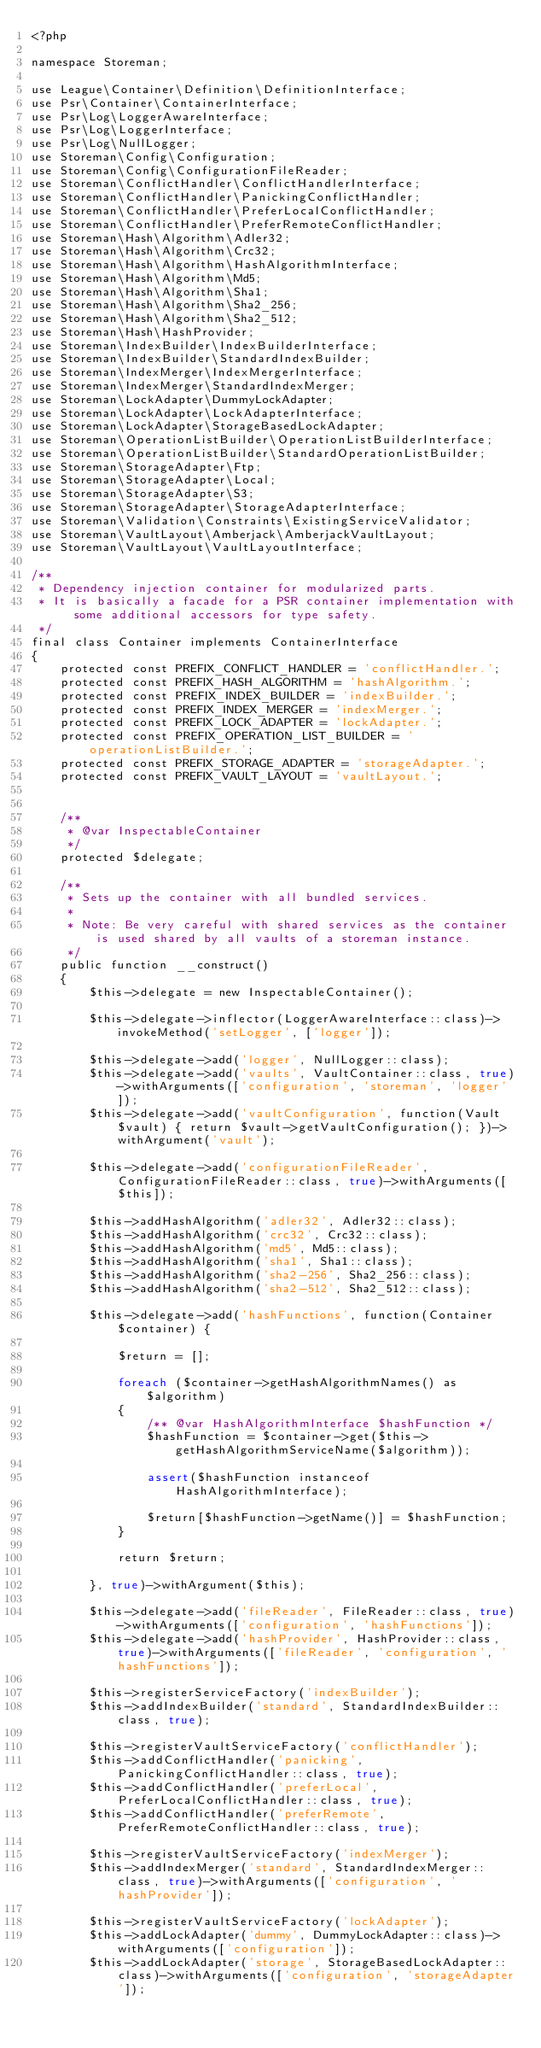Convert code to text. <code><loc_0><loc_0><loc_500><loc_500><_PHP_><?php

namespace Storeman;

use League\Container\Definition\DefinitionInterface;
use Psr\Container\ContainerInterface;
use Psr\Log\LoggerAwareInterface;
use Psr\Log\LoggerInterface;
use Psr\Log\NullLogger;
use Storeman\Config\Configuration;
use Storeman\Config\ConfigurationFileReader;
use Storeman\ConflictHandler\ConflictHandlerInterface;
use Storeman\ConflictHandler\PanickingConflictHandler;
use Storeman\ConflictHandler\PreferLocalConflictHandler;
use Storeman\ConflictHandler\PreferRemoteConflictHandler;
use Storeman\Hash\Algorithm\Adler32;
use Storeman\Hash\Algorithm\Crc32;
use Storeman\Hash\Algorithm\HashAlgorithmInterface;
use Storeman\Hash\Algorithm\Md5;
use Storeman\Hash\Algorithm\Sha1;
use Storeman\Hash\Algorithm\Sha2_256;
use Storeman\Hash\Algorithm\Sha2_512;
use Storeman\Hash\HashProvider;
use Storeman\IndexBuilder\IndexBuilderInterface;
use Storeman\IndexBuilder\StandardIndexBuilder;
use Storeman\IndexMerger\IndexMergerInterface;
use Storeman\IndexMerger\StandardIndexMerger;
use Storeman\LockAdapter\DummyLockAdapter;
use Storeman\LockAdapter\LockAdapterInterface;
use Storeman\LockAdapter\StorageBasedLockAdapter;
use Storeman\OperationListBuilder\OperationListBuilderInterface;
use Storeman\OperationListBuilder\StandardOperationListBuilder;
use Storeman\StorageAdapter\Ftp;
use Storeman\StorageAdapter\Local;
use Storeman\StorageAdapter\S3;
use Storeman\StorageAdapter\StorageAdapterInterface;
use Storeman\Validation\Constraints\ExistingServiceValidator;
use Storeman\VaultLayout\Amberjack\AmberjackVaultLayout;
use Storeman\VaultLayout\VaultLayoutInterface;

/**
 * Dependency injection container for modularized parts.
 * It is basically a facade for a PSR container implementation with some additional accessors for type safety.
 */
final class Container implements ContainerInterface
{
    protected const PREFIX_CONFLICT_HANDLER = 'conflictHandler.';
    protected const PREFIX_HASH_ALGORITHM = 'hashAlgorithm.';
    protected const PREFIX_INDEX_BUILDER = 'indexBuilder.';
    protected const PREFIX_INDEX_MERGER = 'indexMerger.';
    protected const PREFIX_LOCK_ADAPTER = 'lockAdapter.';
    protected const PREFIX_OPERATION_LIST_BUILDER = 'operationListBuilder.';
    protected const PREFIX_STORAGE_ADAPTER = 'storageAdapter.';
    protected const PREFIX_VAULT_LAYOUT = 'vaultLayout.';


    /**
     * @var InspectableContainer
     */
    protected $delegate;

    /**
     * Sets up the container with all bundled services.
     *
     * Note: Be very careful with shared services as the container is used shared by all vaults of a storeman instance.
     */
    public function __construct()
    {
        $this->delegate = new InspectableContainer();

        $this->delegate->inflector(LoggerAwareInterface::class)->invokeMethod('setLogger', ['logger']);

        $this->delegate->add('logger', NullLogger::class);
        $this->delegate->add('vaults', VaultContainer::class, true)->withArguments(['configuration', 'storeman', 'logger']);
        $this->delegate->add('vaultConfiguration', function(Vault $vault) { return $vault->getVaultConfiguration(); })->withArgument('vault');

        $this->delegate->add('configurationFileReader', ConfigurationFileReader::class, true)->withArguments([$this]);

        $this->addHashAlgorithm('adler32', Adler32::class);
        $this->addHashAlgorithm('crc32', Crc32::class);
        $this->addHashAlgorithm('md5', Md5::class);
        $this->addHashAlgorithm('sha1', Sha1::class);
        $this->addHashAlgorithm('sha2-256', Sha2_256::class);
        $this->addHashAlgorithm('sha2-512', Sha2_512::class);

        $this->delegate->add('hashFunctions', function(Container $container) {

            $return = [];

            foreach ($container->getHashAlgorithmNames() as $algorithm)
            {
                /** @var HashAlgorithmInterface $hashFunction */
                $hashFunction = $container->get($this->getHashAlgorithmServiceName($algorithm));

                assert($hashFunction instanceof HashAlgorithmInterface);

                $return[$hashFunction->getName()] = $hashFunction;
            }

            return $return;

        }, true)->withArgument($this);

        $this->delegate->add('fileReader', FileReader::class, true)->withArguments(['configuration', 'hashFunctions']);
        $this->delegate->add('hashProvider', HashProvider::class, true)->withArguments(['fileReader', 'configuration', 'hashFunctions']);

        $this->registerServiceFactory('indexBuilder');
        $this->addIndexBuilder('standard', StandardIndexBuilder::class, true);

        $this->registerVaultServiceFactory('conflictHandler');
        $this->addConflictHandler('panicking', PanickingConflictHandler::class, true);
        $this->addConflictHandler('preferLocal', PreferLocalConflictHandler::class, true);
        $this->addConflictHandler('preferRemote', PreferRemoteConflictHandler::class, true);

        $this->registerVaultServiceFactory('indexMerger');
        $this->addIndexMerger('standard', StandardIndexMerger::class, true)->withArguments(['configuration', 'hashProvider']);

        $this->registerVaultServiceFactory('lockAdapter');
        $this->addLockAdapter('dummy', DummyLockAdapter::class)->withArguments(['configuration']);
        $this->addLockAdapter('storage', StorageBasedLockAdapter::class)->withArguments(['configuration', 'storageAdapter']);
</code> 